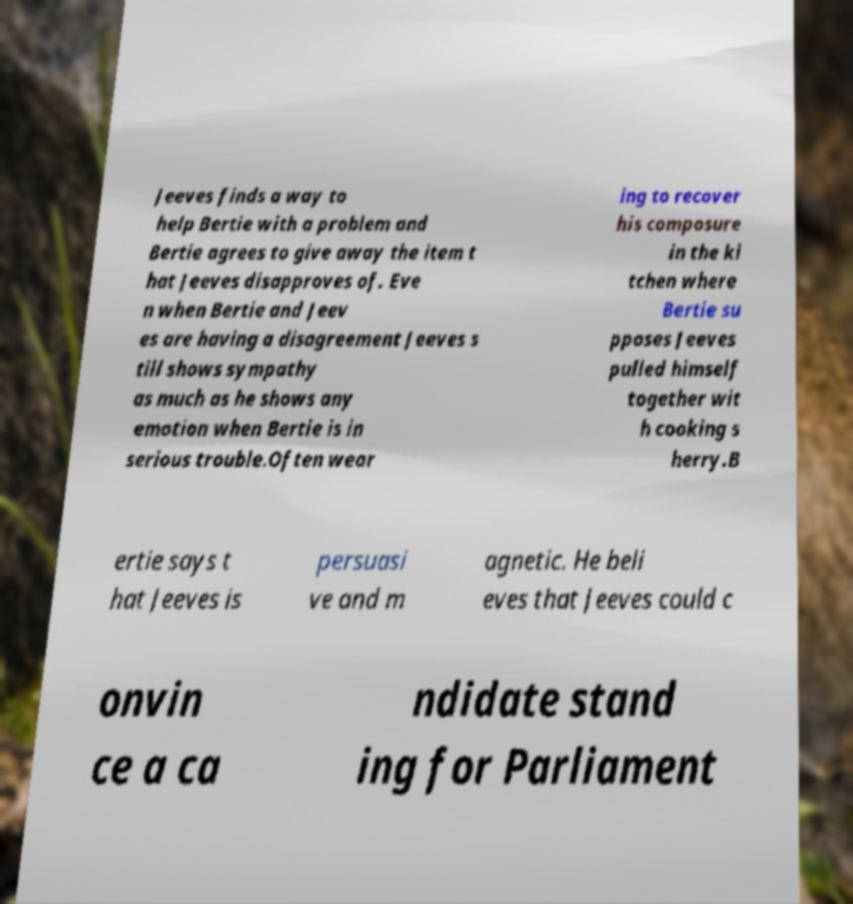Can you accurately transcribe the text from the provided image for me? Jeeves finds a way to help Bertie with a problem and Bertie agrees to give away the item t hat Jeeves disapproves of. Eve n when Bertie and Jeev es are having a disagreement Jeeves s till shows sympathy as much as he shows any emotion when Bertie is in serious trouble.Often wear ing to recover his composure in the ki tchen where Bertie su pposes Jeeves pulled himself together wit h cooking s herry.B ertie says t hat Jeeves is persuasi ve and m agnetic. He beli eves that Jeeves could c onvin ce a ca ndidate stand ing for Parliament 